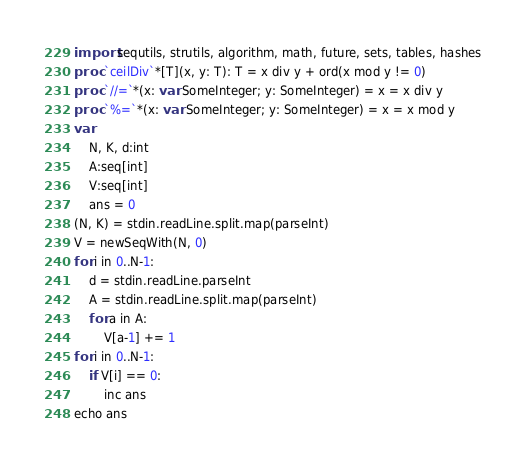Convert code to text. <code><loc_0><loc_0><loc_500><loc_500><_Nim_>import sequtils, strutils, algorithm, math, future, sets, tables, hashes
proc `ceilDiv`*[T](x, y: T): T = x div y + ord(x mod y != 0)
proc `//=`*(x: var SomeInteger; y: SomeInteger) = x = x div y
proc `%=`*(x: var SomeInteger; y: SomeInteger) = x = x mod y
var
    N, K, d:int
    A:seq[int]
    V:seq[int]
    ans = 0
(N, K) = stdin.readLine.split.map(parseInt)
V = newSeqWith(N, 0)
for i in 0..N-1:
    d = stdin.readLine.parseInt
    A = stdin.readLine.split.map(parseInt)
    for a in A:
        V[a-1] += 1
for i in 0..N-1:
    if V[i] == 0:
        inc ans
echo ans
</code> 